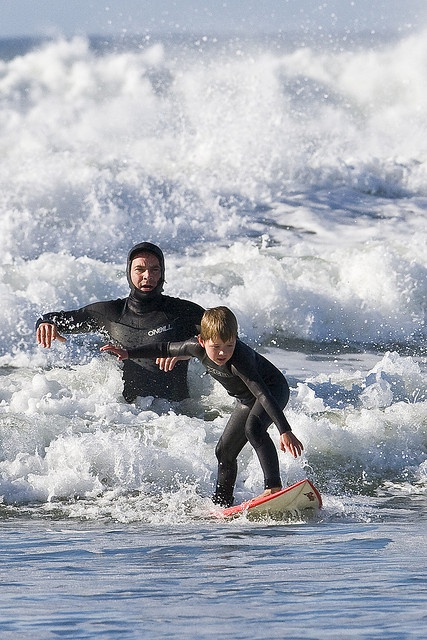Describe the objects in this image and their specific colors. I can see people in darkgray, black, gray, and lightgray tones, people in darkgray, black, gray, maroon, and lightgray tones, and surfboard in darkgray, gray, and lightpink tones in this image. 